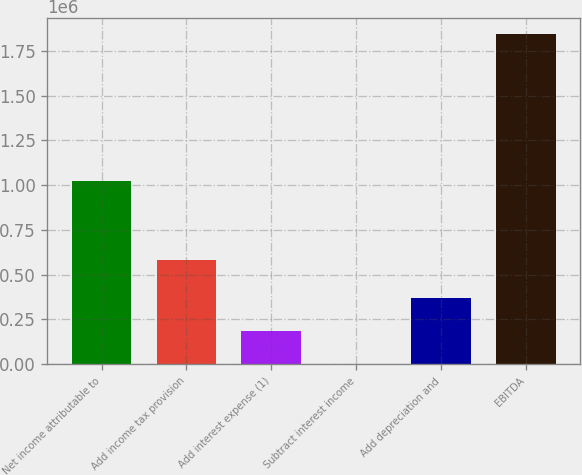Convert chart. <chart><loc_0><loc_0><loc_500><loc_500><bar_chart><fcel>Net income attributable to<fcel>Add income tax provision<fcel>Add interest expense (1)<fcel>Subtract interest income<fcel>Add depreciation and<fcel>EBITDA<nl><fcel>1.0234e+06<fcel>581991<fcel>185369<fcel>1284<fcel>369454<fcel>1.84213e+06<nl></chart> 